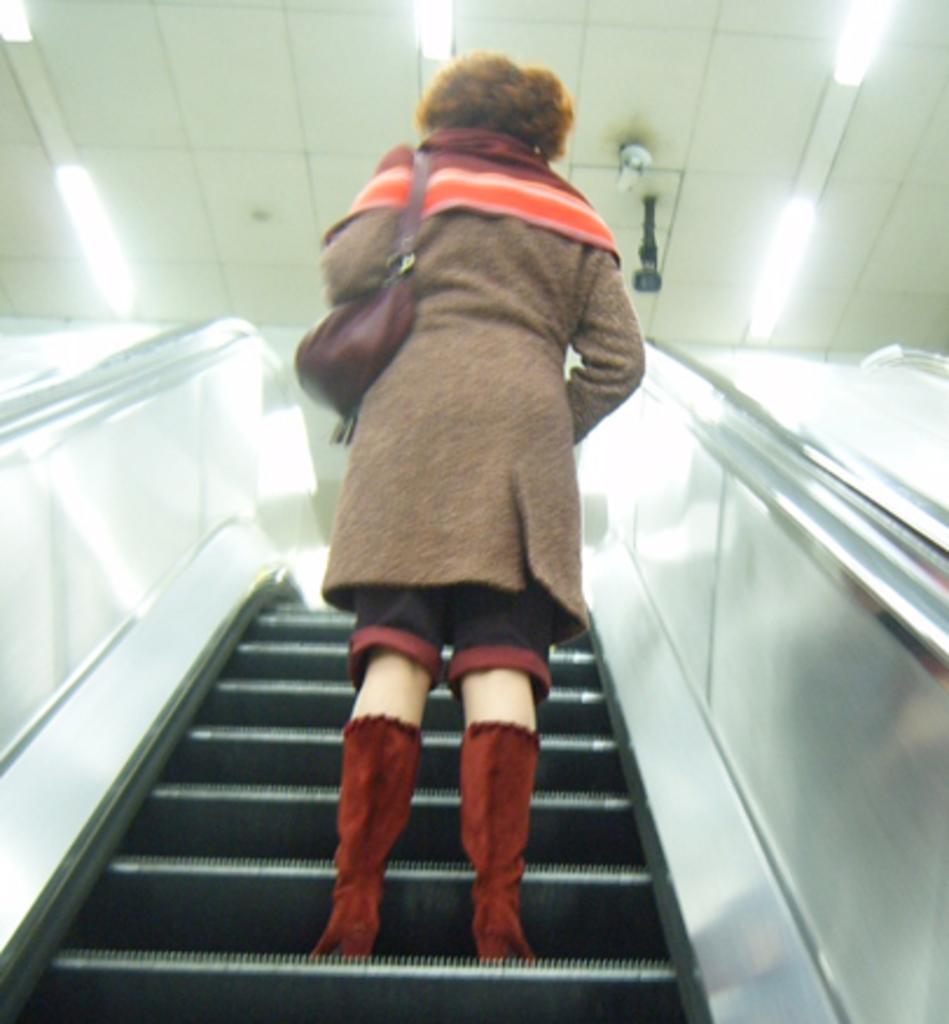Can you describe this image briefly? In this picture, we can see a person standing on the escalator with bag and we can see the roof and some lights and objects attached to the roof. 